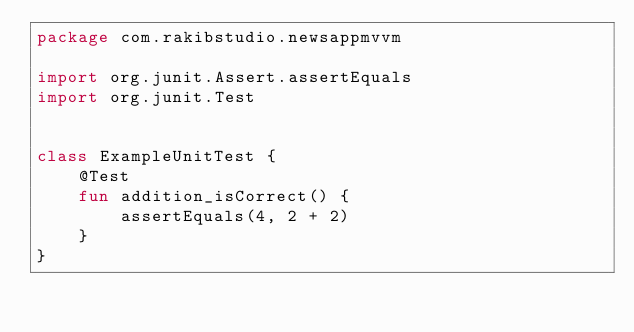Convert code to text. <code><loc_0><loc_0><loc_500><loc_500><_Kotlin_>package com.rakibstudio.newsappmvvm

import org.junit.Assert.assertEquals
import org.junit.Test


class ExampleUnitTest {
    @Test
    fun addition_isCorrect() {
        assertEquals(4, 2 + 2)
    }
}</code> 